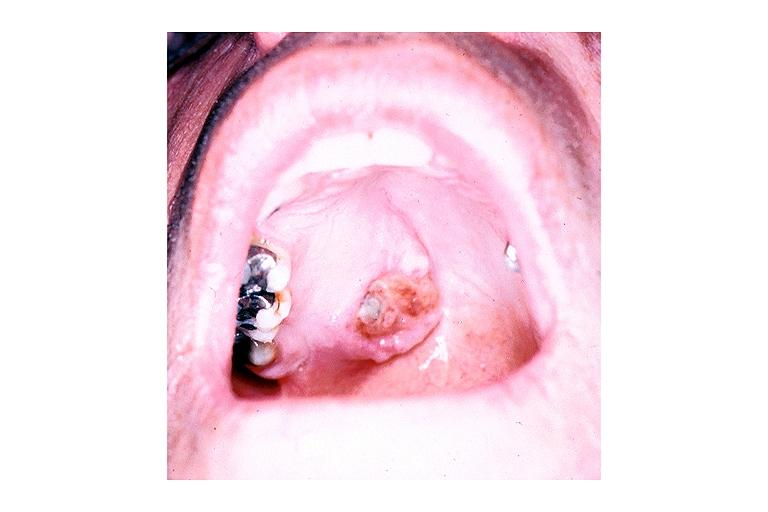what is present?
Answer the question using a single word or phrase. Oral 